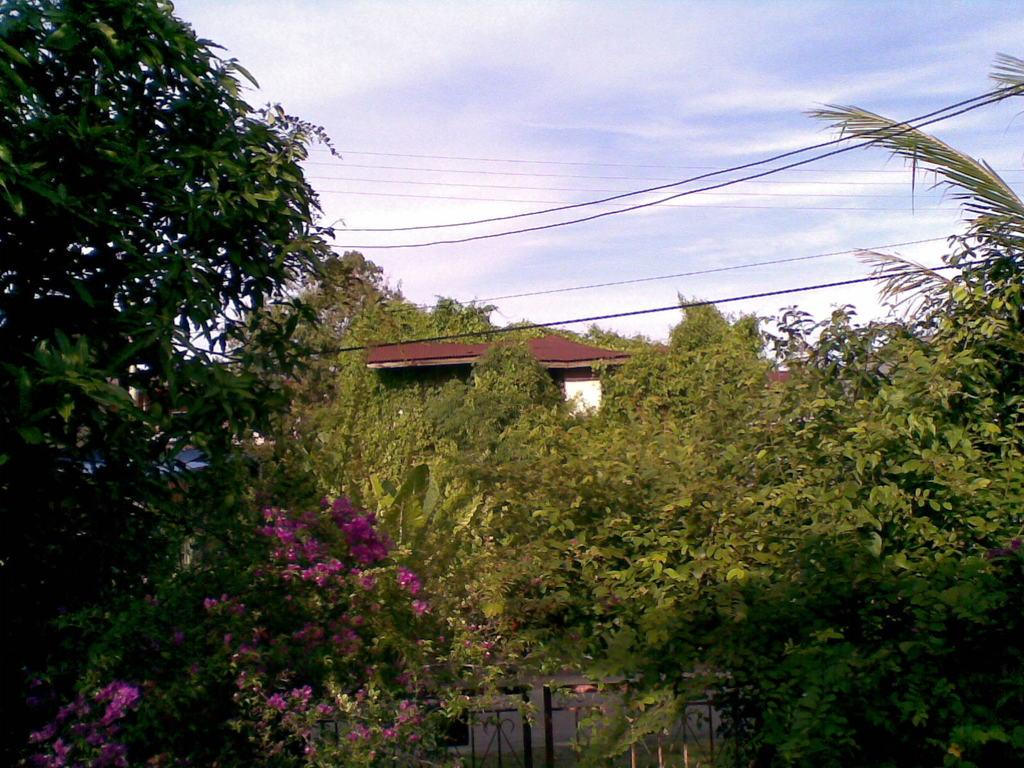What type of flowers can be seen in the image? There are pink color flowers in the image. Where are the flowers located? The flowers are on plants. What structure is visible in the image? There is a house in the image. How is the house positioned in relation to the plants and trees? The house is between plants and trees. What can be seen in the background of the image? There are clouds and the sky visible in the background of the image. What type of grain is being harvested in the image? There is no grain present in the image; it features pink color flowers, plants, a house, and a sky background. 